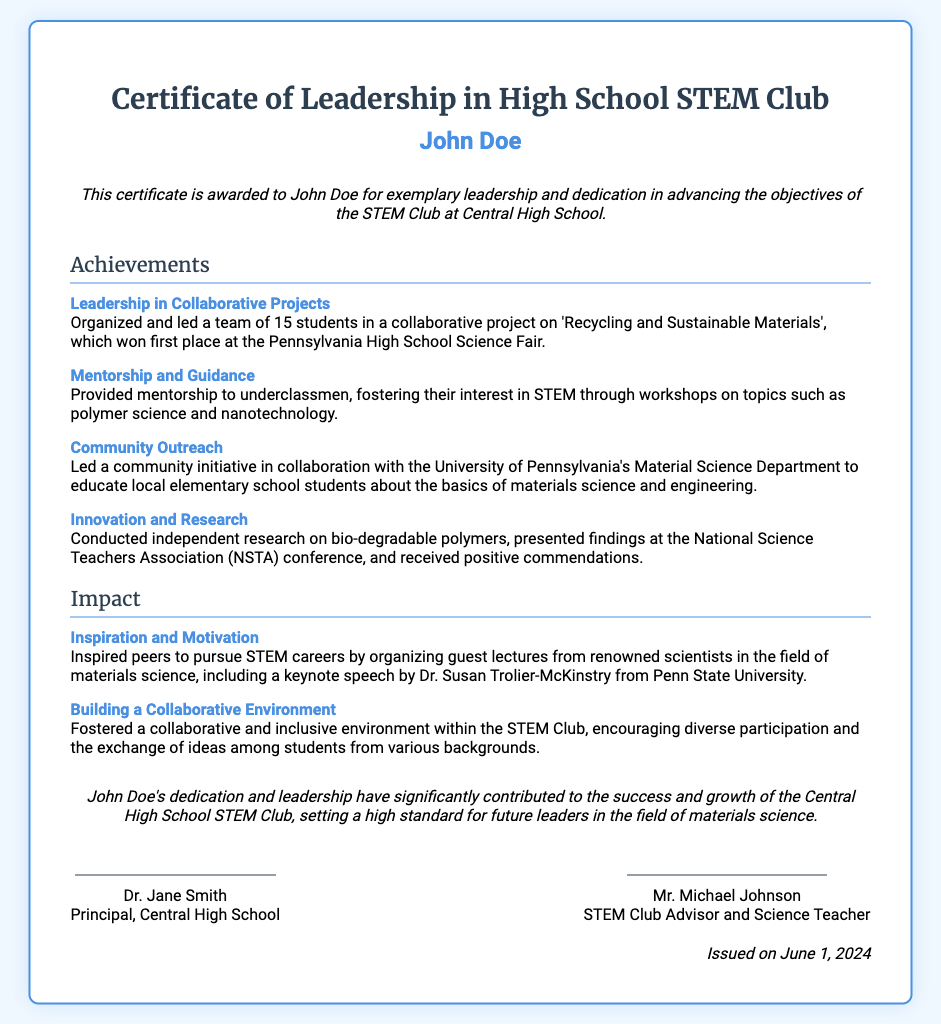What is the name of the recipient? The recipient's name is clearly stated at the top of the certificate.
Answer: John Doe What organization is the award associated with? The certificate mentions the name of the club at Central High School.
Answer: STEM Club What project did John Doe lead? The achievements section mentions a specific project that won an award.
Answer: Recycling and Sustainable Materials What award did the project win? The document specifies the outcome of the project at a particular science fair.
Answer: First place Who is the principal of Central High School? The signature section provides the name of the principal.
Answer: Dr. Jane Smith On what date was the certificate issued? The issuance date is stated at the bottom of the document.
Answer: June 1, 2024 What was one of the topics of the workshops provided by John Doe? The achievements section includes specific topics covered in the workshops.
Answer: Polymer science Who gave a keynote speech at the guest lecture organized by John Doe? The impact section refers to a renowned scientist who addressed the audience.
Answer: Dr. Susan Trolier-McKinstry What type of initiative did John Doe lead with the University of Pennsylvania? The impact section outlines the nature of the initiative in collaboration with a local university.
Answer: Community initiative 